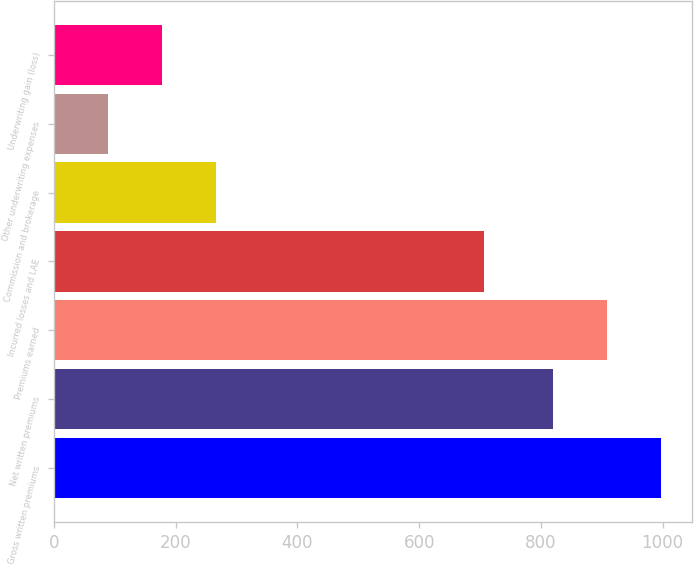Convert chart. <chart><loc_0><loc_0><loc_500><loc_500><bar_chart><fcel>Gross written premiums<fcel>Net written premiums<fcel>Premiums earned<fcel>Incurred losses and LAE<fcel>Commission and brokerage<fcel>Other underwriting expenses<fcel>Underwriting gain (loss)<nl><fcel>997.72<fcel>820.5<fcel>909.11<fcel>705.9<fcel>266.72<fcel>89.5<fcel>178.11<nl></chart> 